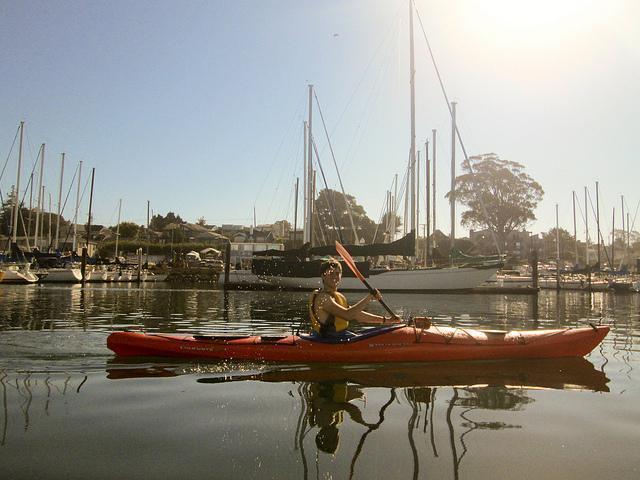What is the person riding in?
Answer the question by selecting the correct answer among the 4 following choices and explain your choice with a short sentence. The answer should be formatted with the following format: `Answer: choice
Rationale: rationale.`
Options: Airplane, sled, helicopter, canoe. Answer: canoe.
Rationale: The person is not in a land or air vehicle. the person is above water. 